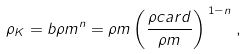<formula> <loc_0><loc_0><loc_500><loc_500>\rho _ { K } = b \rho m ^ { n } = \rho m \left ( \frac { \rho c a r d } { \rho m } \right ) ^ { \, 1 - n \, } ,</formula> 